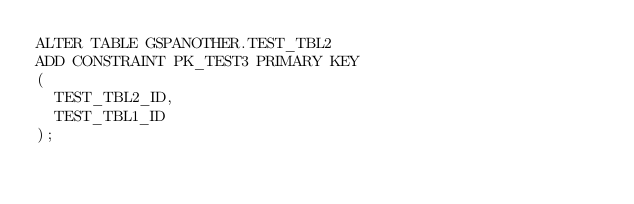<code> <loc_0><loc_0><loc_500><loc_500><_SQL_>ALTER TABLE GSPANOTHER.TEST_TBL2
ADD CONSTRAINT PK_TEST3 PRIMARY KEY
(
  TEST_TBL2_ID,
  TEST_TBL1_ID
);
</code> 